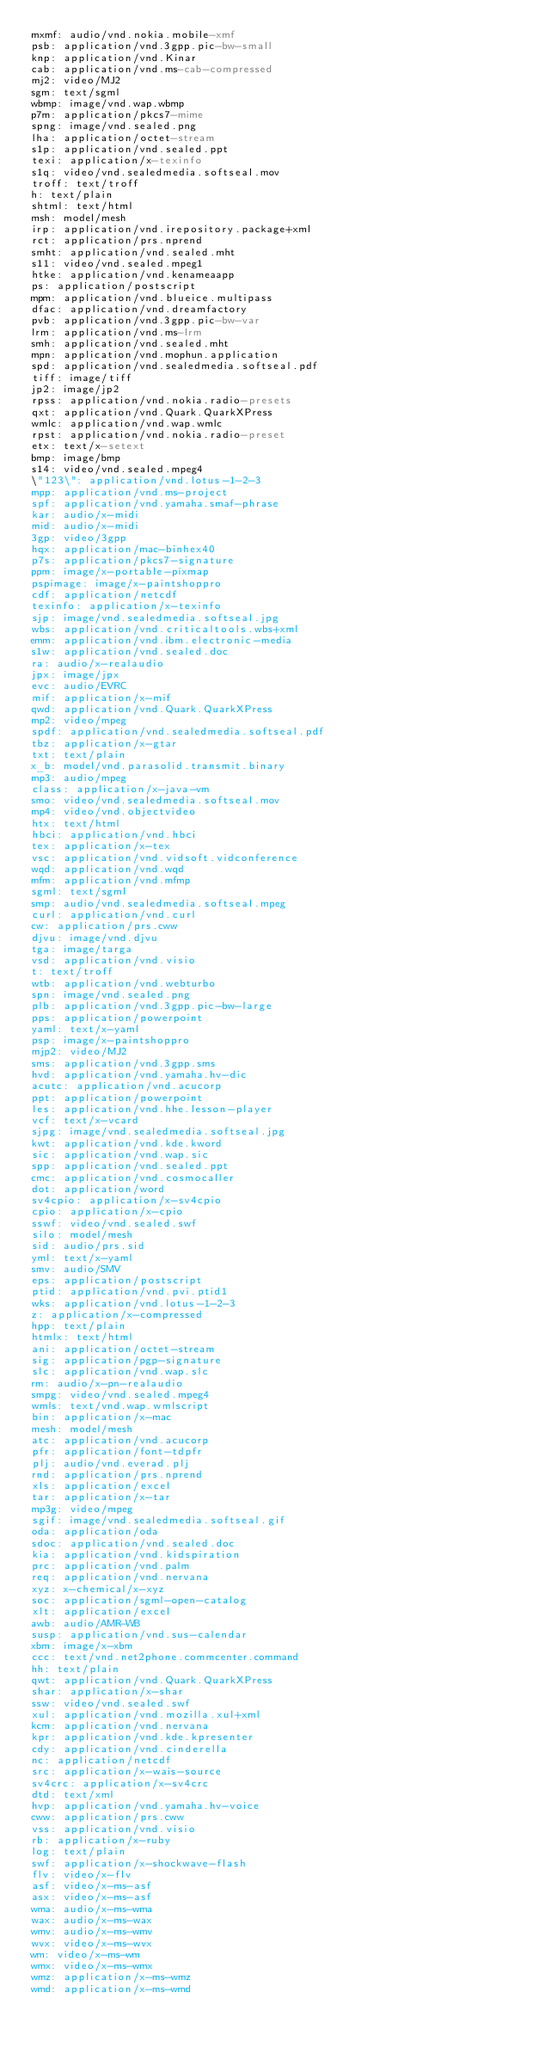<code> <loc_0><loc_0><loc_500><loc_500><_YAML_>mxmf: audio/vnd.nokia.mobile-xmf
psb: application/vnd.3gpp.pic-bw-small
knp: application/vnd.Kinar
cab: application/vnd.ms-cab-compressed
mj2: video/MJ2
sgm: text/sgml
wbmp: image/vnd.wap.wbmp
p7m: application/pkcs7-mime
spng: image/vnd.sealed.png
lha: application/octet-stream
s1p: application/vnd.sealed.ppt
texi: application/x-texinfo
s1q: video/vnd.sealedmedia.softseal.mov
troff: text/troff
h: text/plain
shtml: text/html
msh: model/mesh
irp: application/vnd.irepository.package+xml
rct: application/prs.nprend
smht: application/vnd.sealed.mht
s11: video/vnd.sealed.mpeg1
htke: application/vnd.kenameaapp
ps: application/postscript
mpm: application/vnd.blueice.multipass
dfac: application/vnd.dreamfactory
pvb: application/vnd.3gpp.pic-bw-var
lrm: application/vnd.ms-lrm
smh: application/vnd.sealed.mht
mpn: application/vnd.mophun.application
spd: application/vnd.sealedmedia.softseal.pdf
tiff: image/tiff
jp2: image/jp2
rpss: application/vnd.nokia.radio-presets
qxt: application/vnd.Quark.QuarkXPress
wmlc: application/vnd.wap.wmlc
rpst: application/vnd.nokia.radio-preset
etx: text/x-setext
bmp: image/bmp
s14: video/vnd.sealed.mpeg4
\"123\": application/vnd.lotus-1-2-3
mpp: application/vnd.ms-project
spf: application/vnd.yamaha.smaf-phrase
kar: audio/x-midi
mid: audio/x-midi
3gp: video/3gpp
hqx: application/mac-binhex40
p7s: application/pkcs7-signature
ppm: image/x-portable-pixmap
pspimage: image/x-paintshoppro
cdf: application/netcdf
texinfo: application/x-texinfo
sjp: image/vnd.sealedmedia.softseal.jpg
wbs: application/vnd.criticaltools.wbs+xml
emm: application/vnd.ibm.electronic-media
s1w: application/vnd.sealed.doc
ra: audio/x-realaudio
jpx: image/jpx
evc: audio/EVRC
mif: application/x-mif
qwd: application/vnd.Quark.QuarkXPress
mp2: video/mpeg
spdf: application/vnd.sealedmedia.softseal.pdf
tbz: application/x-gtar
txt: text/plain
x_b: model/vnd.parasolid.transmit.binary
mp3: audio/mpeg
class: application/x-java-vm
smo: video/vnd.sealedmedia.softseal.mov
mp4: video/vnd.objectvideo
htx: text/html
hbci: application/vnd.hbci
tex: application/x-tex
vsc: application/vnd.vidsoft.vidconference
wqd: application/vnd.wqd
mfm: application/vnd.mfmp
sgml: text/sgml
smp: audio/vnd.sealedmedia.softseal.mpeg
curl: application/vnd.curl
cw: application/prs.cww
djvu: image/vnd.djvu
tga: image/targa
vsd: application/vnd.visio
t: text/troff
wtb: application/vnd.webturbo
spn: image/vnd.sealed.png
plb: application/vnd.3gpp.pic-bw-large
pps: application/powerpoint
yaml: text/x-yaml
psp: image/x-paintshoppro
mjp2: video/MJ2
sms: application/vnd.3gpp.sms
hvd: application/vnd.yamaha.hv-dic
acutc: application/vnd.acucorp
ppt: application/powerpoint
les: application/vnd.hhe.lesson-player
vcf: text/x-vcard
sjpg: image/vnd.sealedmedia.softseal.jpg
kwt: application/vnd.kde.kword
sic: application/vnd.wap.sic
spp: application/vnd.sealed.ppt
cmc: application/vnd.cosmocaller
dot: application/word
sv4cpio: application/x-sv4cpio
cpio: application/x-cpio
sswf: video/vnd.sealed.swf
silo: model/mesh
sid: audio/prs.sid
yml: text/x-yaml
smv: audio/SMV
eps: application/postscript
ptid: application/vnd.pvi.ptid1
wks: application/vnd.lotus-1-2-3
z: application/x-compressed
hpp: text/plain
htmlx: text/html
ani: application/octet-stream
sig: application/pgp-signature
slc: application/vnd.wap.slc
rm: audio/x-pn-realaudio
smpg: video/vnd.sealed.mpeg4
wmls: text/vnd.wap.wmlscript
bin: application/x-mac
mesh: model/mesh
atc: application/vnd.acucorp
pfr: application/font-tdpfr
plj: audio/vnd.everad.plj
rnd: application/prs.nprend
xls: application/excel
tar: application/x-tar
mp3g: video/mpeg
sgif: image/vnd.sealedmedia.softseal.gif
oda: application/oda
sdoc: application/vnd.sealed.doc
kia: application/vnd.kidspiration
prc: application/vnd.palm
req: application/vnd.nervana
xyz: x-chemical/x-xyz
soc: application/sgml-open-catalog
xlt: application/excel
awb: audio/AMR-WB
susp: application/vnd.sus-calendar
xbm: image/x-xbm
ccc: text/vnd.net2phone.commcenter.command
hh: text/plain
qwt: application/vnd.Quark.QuarkXPress
shar: application/x-shar
ssw: video/vnd.sealed.swf
xul: application/vnd.mozilla.xul+xml
kcm: application/vnd.nervana
kpr: application/vnd.kde.kpresenter
cdy: application/vnd.cinderella
nc: application/netcdf
src: application/x-wais-source
sv4crc: application/x-sv4crc
dtd: text/xml
hvp: application/vnd.yamaha.hv-voice
cww: application/prs.cww
vss: application/vnd.visio
rb: application/x-ruby
log: text/plain
swf: application/x-shockwave-flash
flv: video/x-flv
asf: video/x-ms-asf
asx: video/x-ms-asf
wma: audio/x-ms-wma
wax: audio/x-ms-wax
wmv: audio/x-ms-wmv
wvx: video/x-ms-wvx
wm: video/x-ms-wm
wmx: video/x-ms-wmx
wmz: application/x-ms-wmz
wmd: application/x-ms-wmd

</code> 